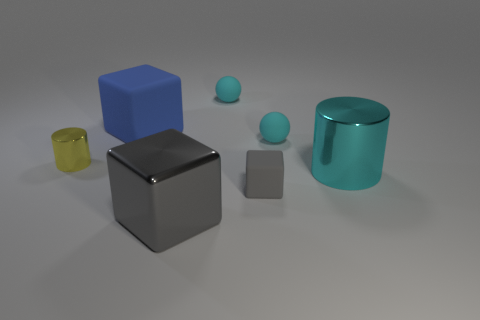Add 3 tiny yellow metallic things. How many objects exist? 10 Subtract all balls. How many objects are left? 5 Subtract all large green rubber cylinders. Subtract all large metal objects. How many objects are left? 5 Add 6 small yellow cylinders. How many small yellow cylinders are left? 7 Add 7 small cyan objects. How many small cyan objects exist? 9 Subtract 0 green cubes. How many objects are left? 7 